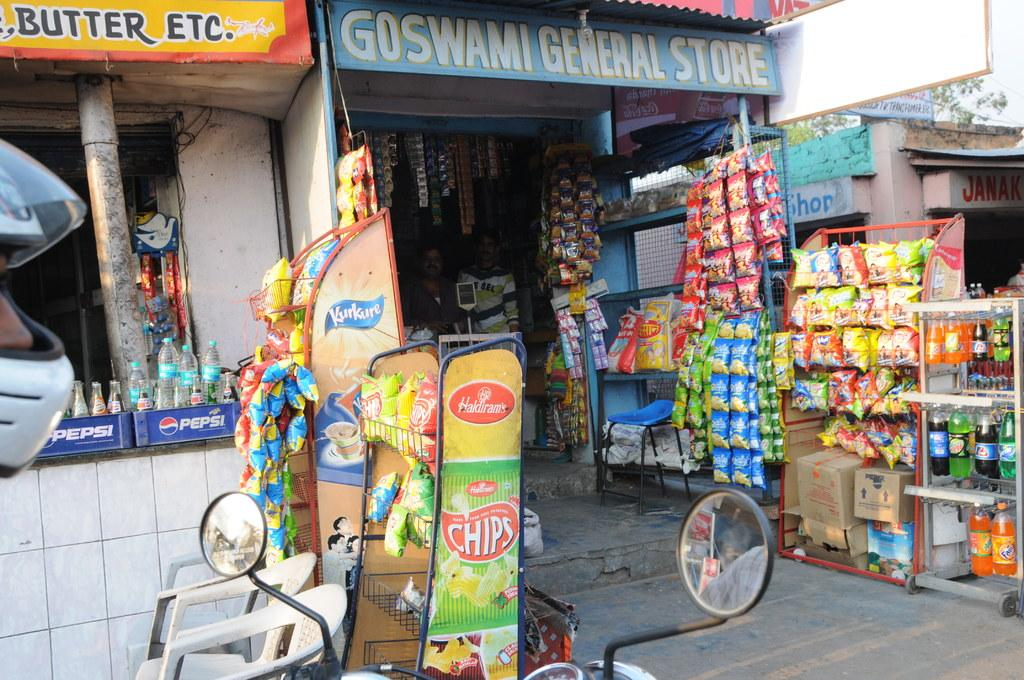<image>
Provide a brief description of the given image. The Goswami General store sells butter, chips and other food products. 